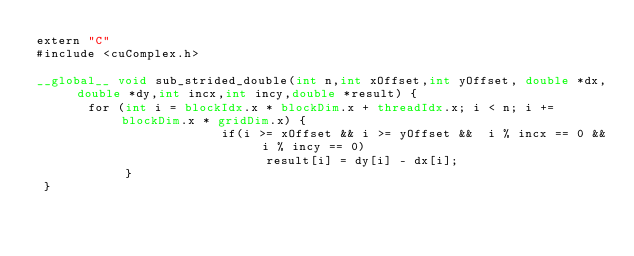<code> <loc_0><loc_0><loc_500><loc_500><_Cuda_>extern "C"
#include <cuComplex.h>

__global__ void sub_strided_double(int n,int xOffset,int yOffset, double *dx, double *dy,int incx,int incy,double *result) {
       for (int i = blockIdx.x * blockDim.x + threadIdx.x; i < n; i += blockDim.x * gridDim.x) {
                         if(i >= xOffset && i >= yOffset &&  i % incx == 0 && i % incy == 0)
                               result[i] = dy[i] - dx[i];
            }
 }


</code> 